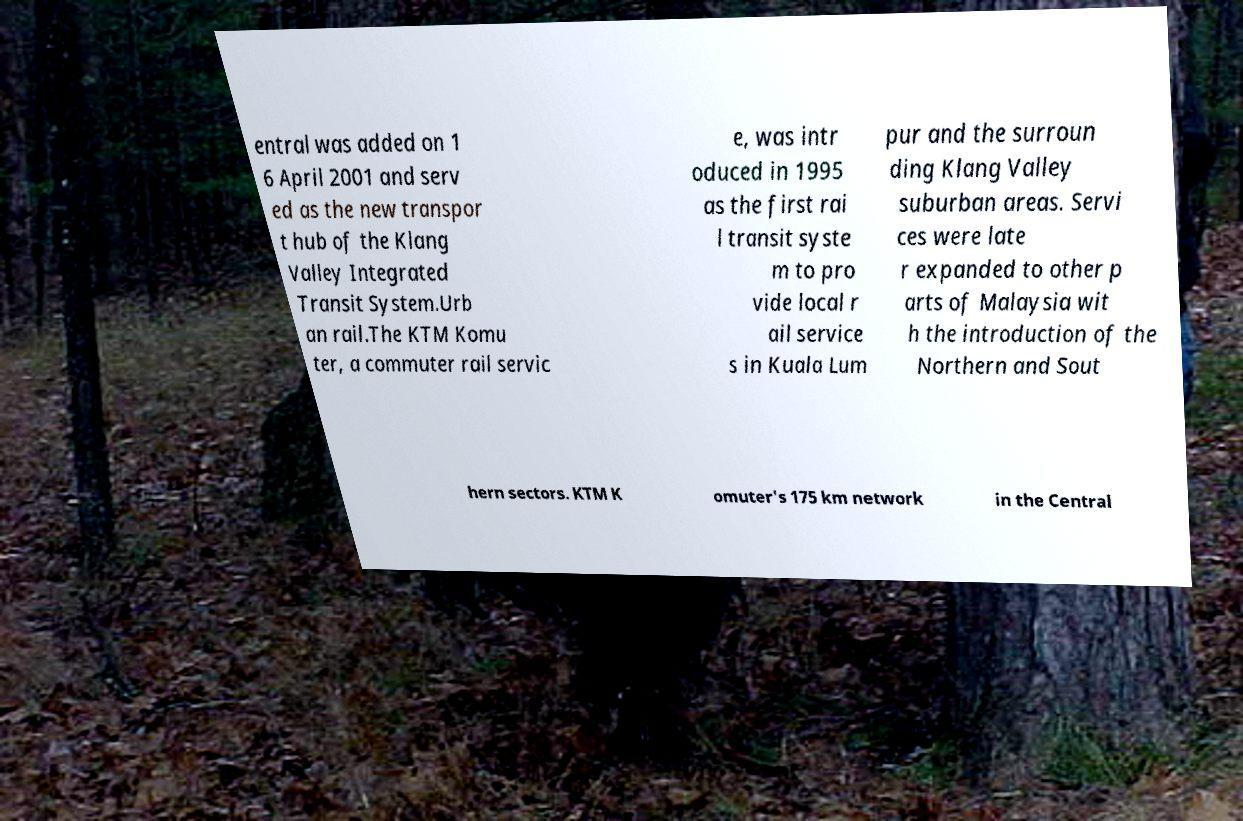Please read and relay the text visible in this image. What does it say? entral was added on 1 6 April 2001 and serv ed as the new transpor t hub of the Klang Valley Integrated Transit System.Urb an rail.The KTM Komu ter, a commuter rail servic e, was intr oduced in 1995 as the first rai l transit syste m to pro vide local r ail service s in Kuala Lum pur and the surroun ding Klang Valley suburban areas. Servi ces were late r expanded to other p arts of Malaysia wit h the introduction of the Northern and Sout hern sectors. KTM K omuter's 175 km network in the Central 